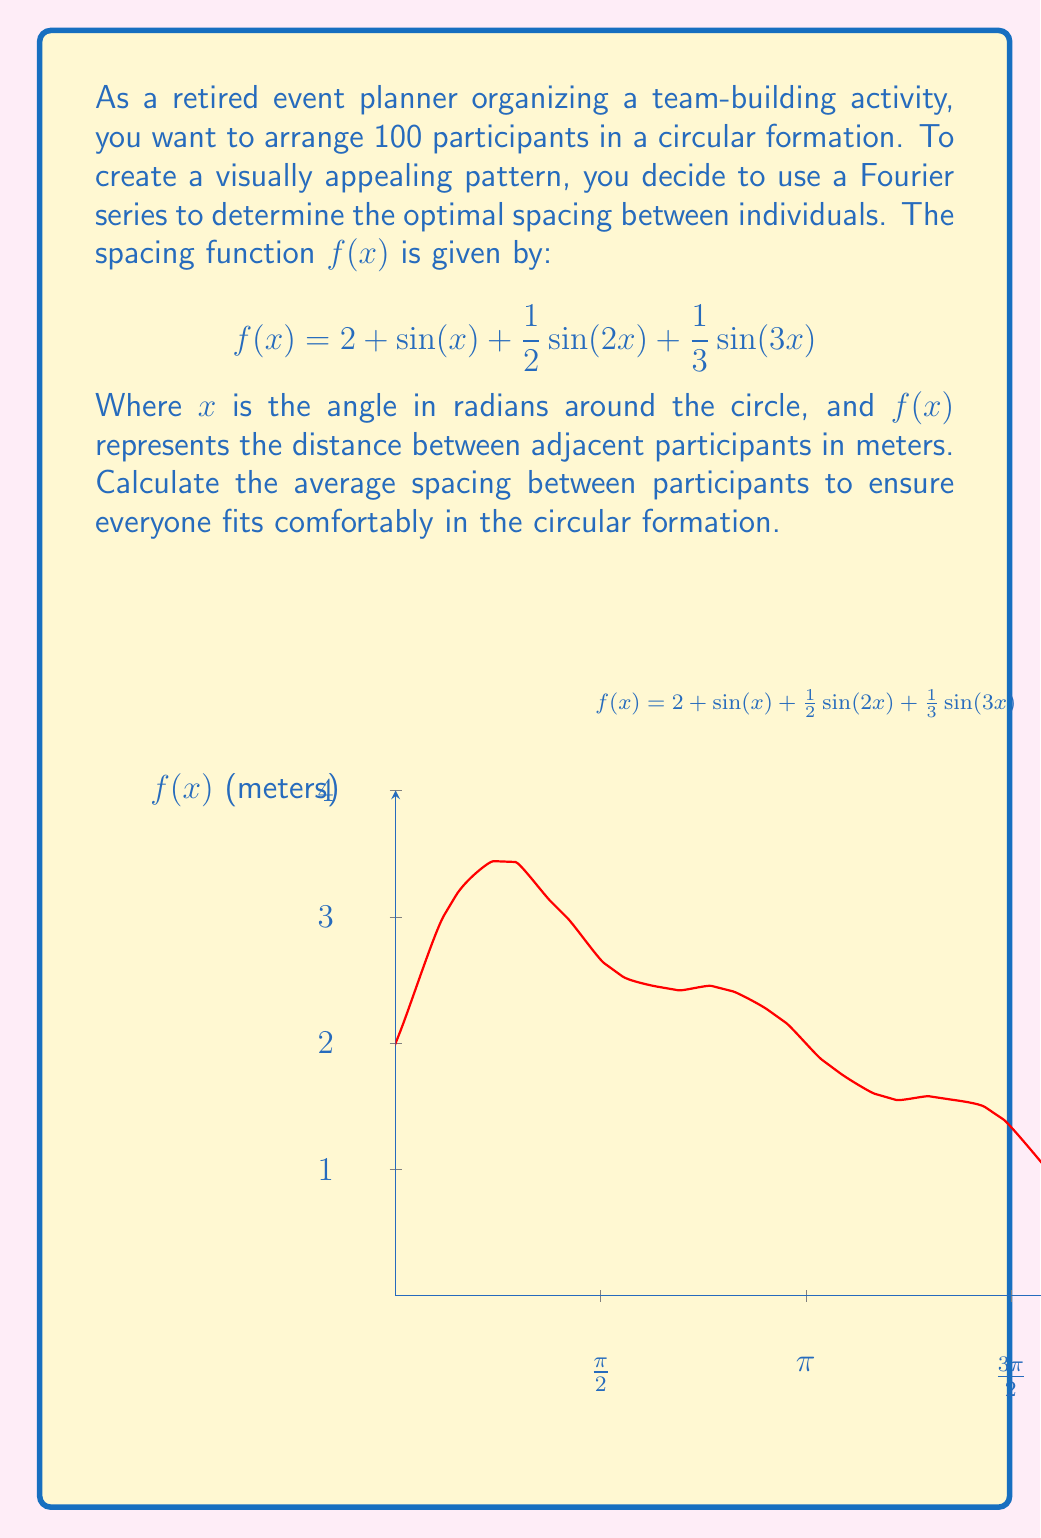Can you solve this math problem? To find the average spacing, we need to calculate the average value of $f(x)$ over one complete revolution (0 to $2\pi$). This can be done using the following steps:

1) The average value of a function $f(x)$ over an interval $[a,b]$ is given by:

   $$\text{Average} = \frac{1}{b-a}\int_a^b f(x) dx$$

2) In our case, $a=0$, $b=2\pi$, so we have:

   $$\text{Average} = \frac{1}{2\pi}\int_0^{2\pi} f(x) dx$$

3) Substituting our function:

   $$\text{Average} = \frac{1}{2\pi}\int_0^{2\pi} (2 + \sin(x) + \frac{1}{2}\sin(2x) + \frac{1}{3}\sin(3x)) dx$$

4) We can integrate each term separately:

   $$\frac{1}{2\pi}\int_0^{2\pi} 2 dx = 2$$

   $$\frac{1}{2\pi}\int_0^{2\pi} \sin(x) dx = 0$$

   $$\frac{1}{2\pi}\int_0^{2\pi} \frac{1}{2}\sin(2x) dx = 0$$

   $$\frac{1}{2\pi}\int_0^{2\pi} \frac{1}{3}\sin(3x) dx = 0$$

5) The integrals of the sine terms are all zero because they complete full cycles over the interval $[0,2\pi]$.

6) Therefore, the average spacing is simply 2 meters.

7) To verify if this spacing allows all 100 participants to fit, we calculate the circumference:

   $$\text{Circumference} = 100 \times 2 = 200 \text{ meters}$$

8) The radius of the circle would be:

   $$r = \frac{200}{2\pi} \approx 31.83 \text{ meters}$$

This is a reasonable size for a large team-building activity.
Answer: 2 meters 